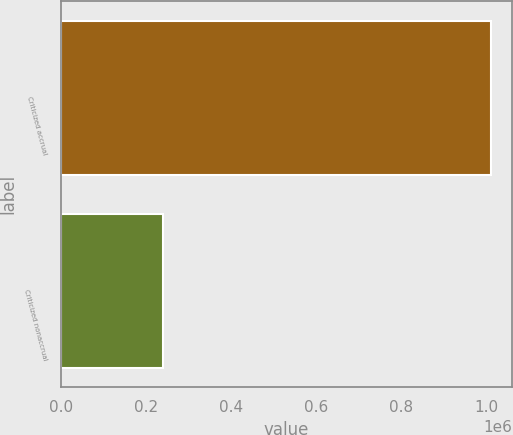Convert chart to OTSL. <chart><loc_0><loc_0><loc_500><loc_500><bar_chart><fcel>Criticized accrual<fcel>Criticized nonaccrual<nl><fcel>1.01117e+06<fcel>240991<nl></chart> 